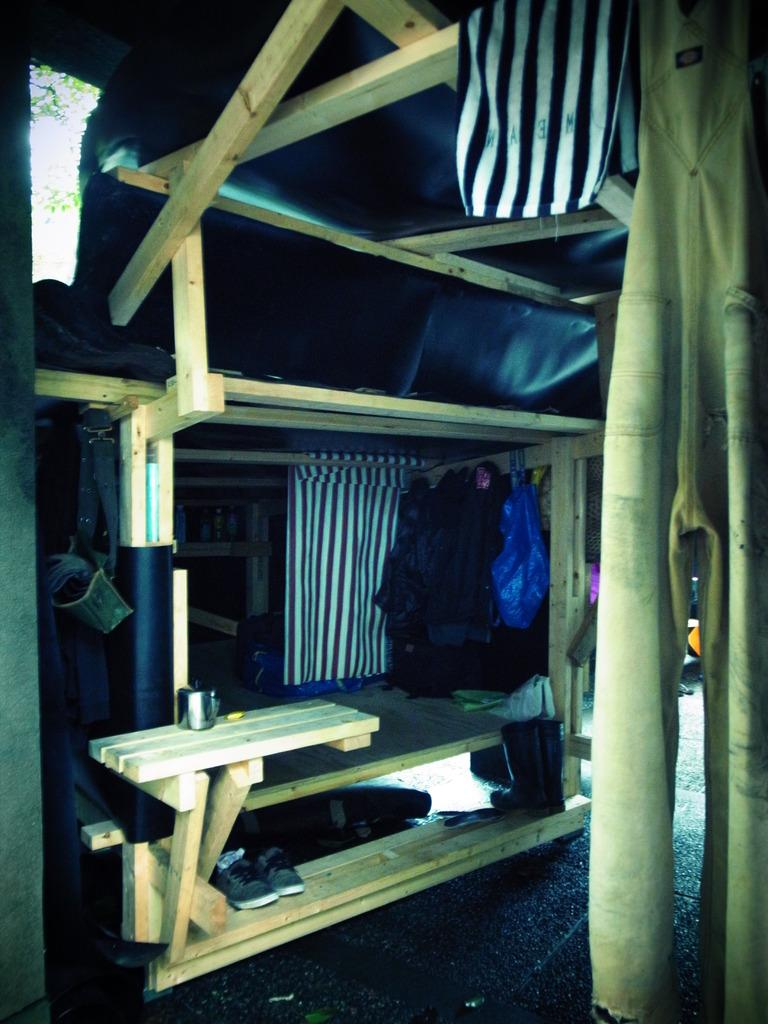What type of material is used for the objects in the image? The wooden objects in the image are made of wood. What else can be seen in the image besides the wooden objects? Clothes, a cover, boots, shoes, miscellaneous items, and tree leaves are present in the image. What is covering the items in the image? A cover is visible in the image. What type of footwear is present in the image? Boots and shoes are in the image. What is at the bottom of the image? The bottom of the image shows a surface. Where are the tree leaves located in the image? Tree leaves are on the left side of the image. What is the process of making the snow in the image? There is no snow present in the image. What type of street is shown in the image? There is no street shown in the image. 